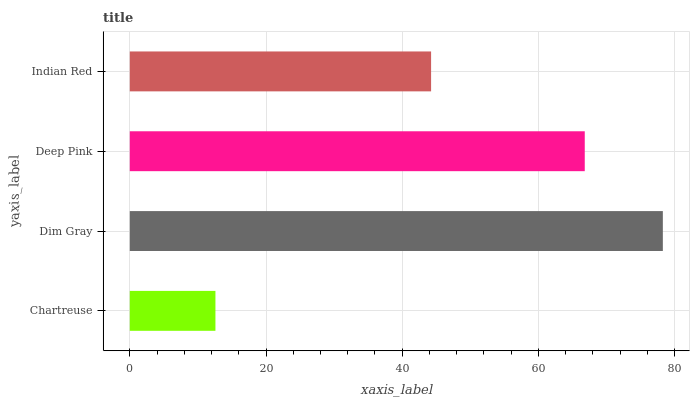Is Chartreuse the minimum?
Answer yes or no. Yes. Is Dim Gray the maximum?
Answer yes or no. Yes. Is Deep Pink the minimum?
Answer yes or no. No. Is Deep Pink the maximum?
Answer yes or no. No. Is Dim Gray greater than Deep Pink?
Answer yes or no. Yes. Is Deep Pink less than Dim Gray?
Answer yes or no. Yes. Is Deep Pink greater than Dim Gray?
Answer yes or no. No. Is Dim Gray less than Deep Pink?
Answer yes or no. No. Is Deep Pink the high median?
Answer yes or no. Yes. Is Indian Red the low median?
Answer yes or no. Yes. Is Dim Gray the high median?
Answer yes or no. No. Is Dim Gray the low median?
Answer yes or no. No. 